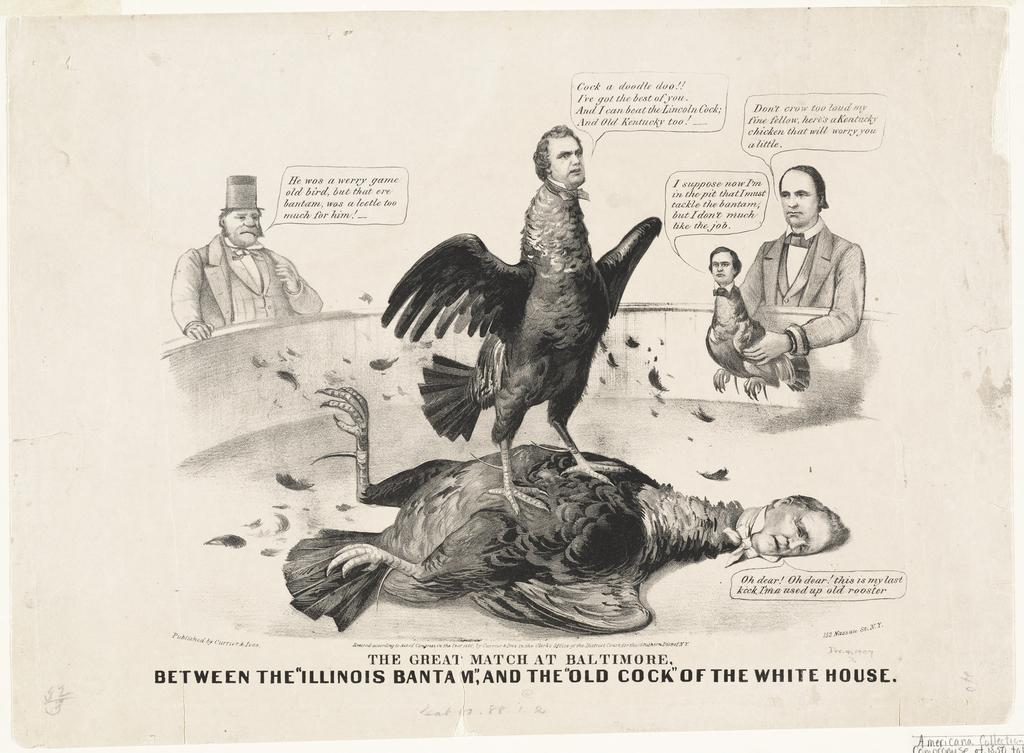What is the main subject of the image? The main subject of the image is a drawing. What can be seen in the drawing? The drawing contains two persons. Are there any words or letters in the image? Yes, there is text present in the image. What type of mountain is visible in the background of the drawing? There is no mountain visible in the drawing; it only contains two persons and text. What position are the two persons in within the drawing? The provided facts do not specify the position or arrangement of the two persons in the drawing. 